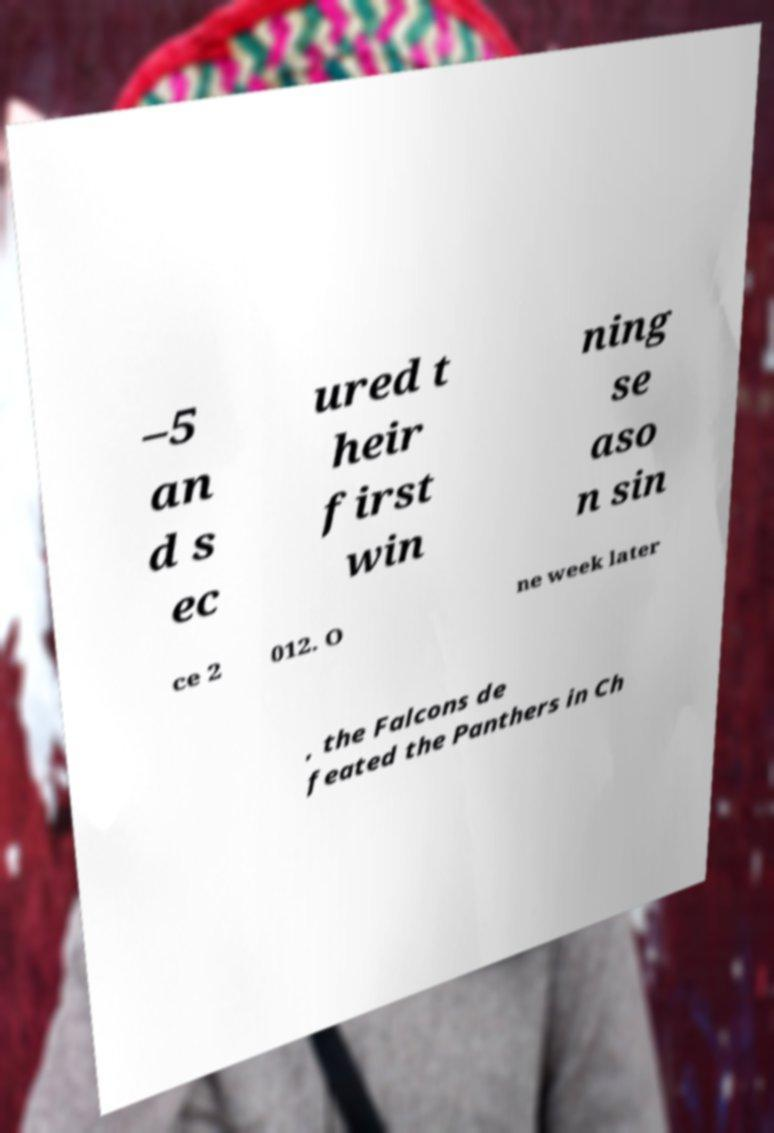Could you extract and type out the text from this image? –5 an d s ec ured t heir first win ning se aso n sin ce 2 012. O ne week later , the Falcons de feated the Panthers in Ch 